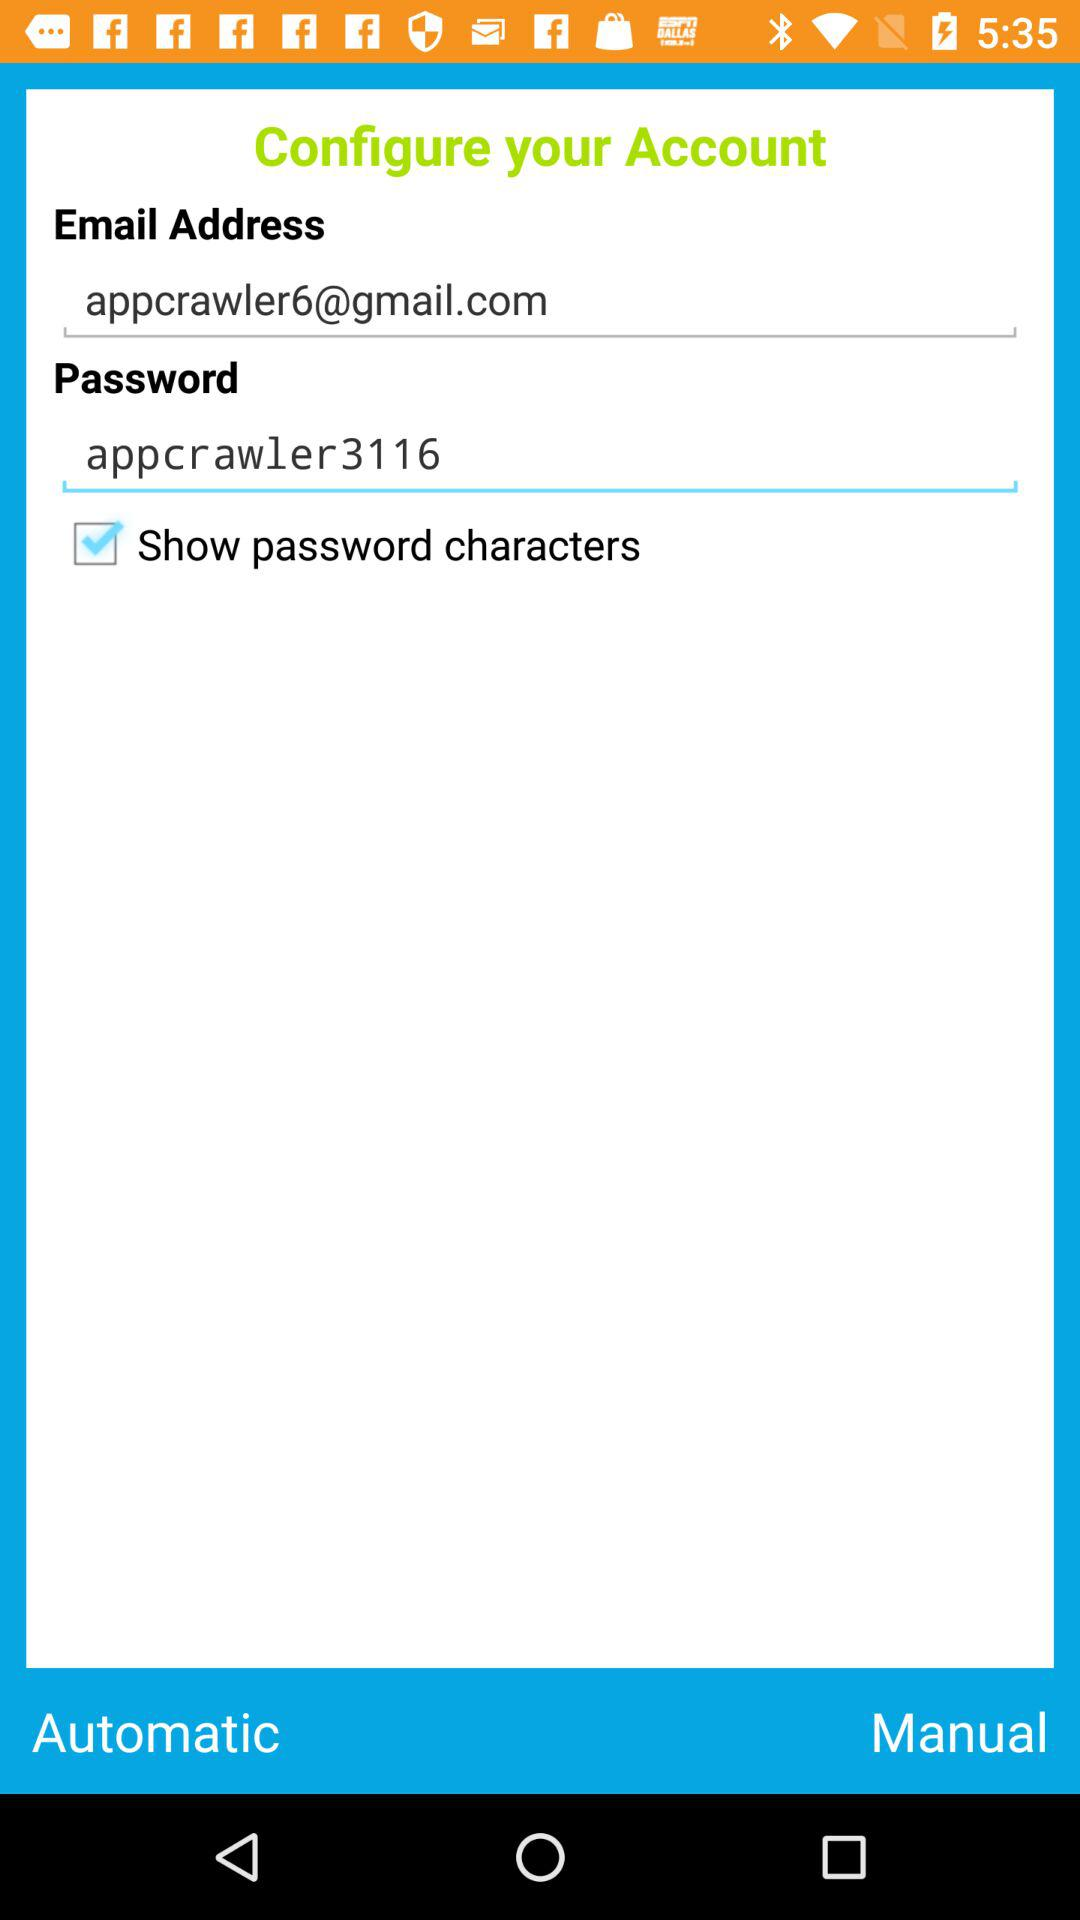What is the email address? The email address is appcrawler6@gmail.com. 